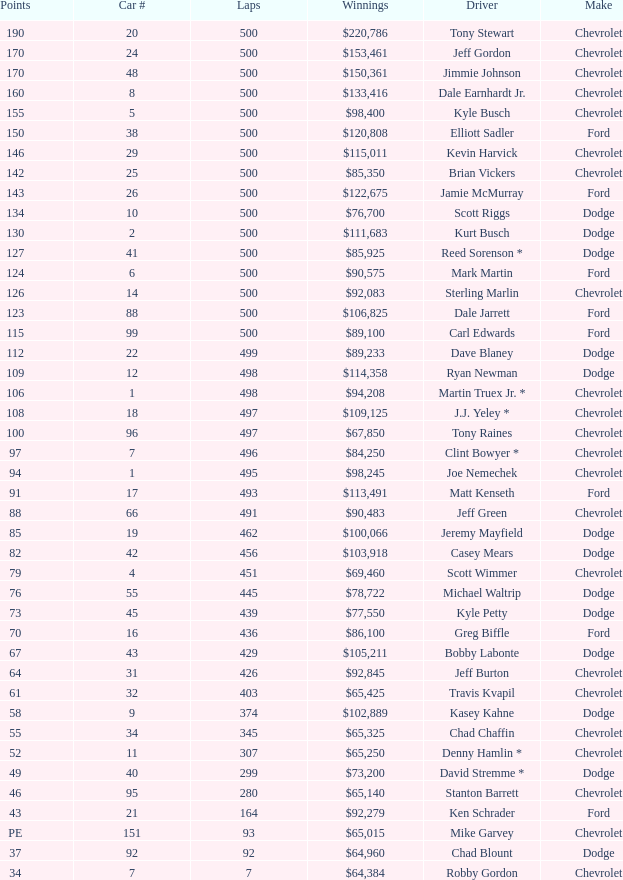What is the average car number of all the drivers with 109 points? 12.0. 